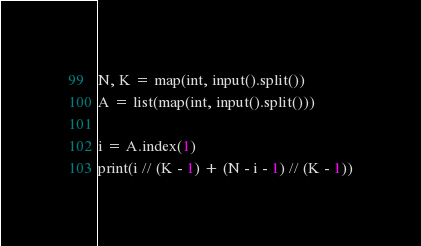<code> <loc_0><loc_0><loc_500><loc_500><_Python_>N, K = map(int, input().split())
A = list(map(int, input().split()))

i = A.index(1)
print(i // (K - 1) + (N - i - 1) // (K - 1))
</code> 